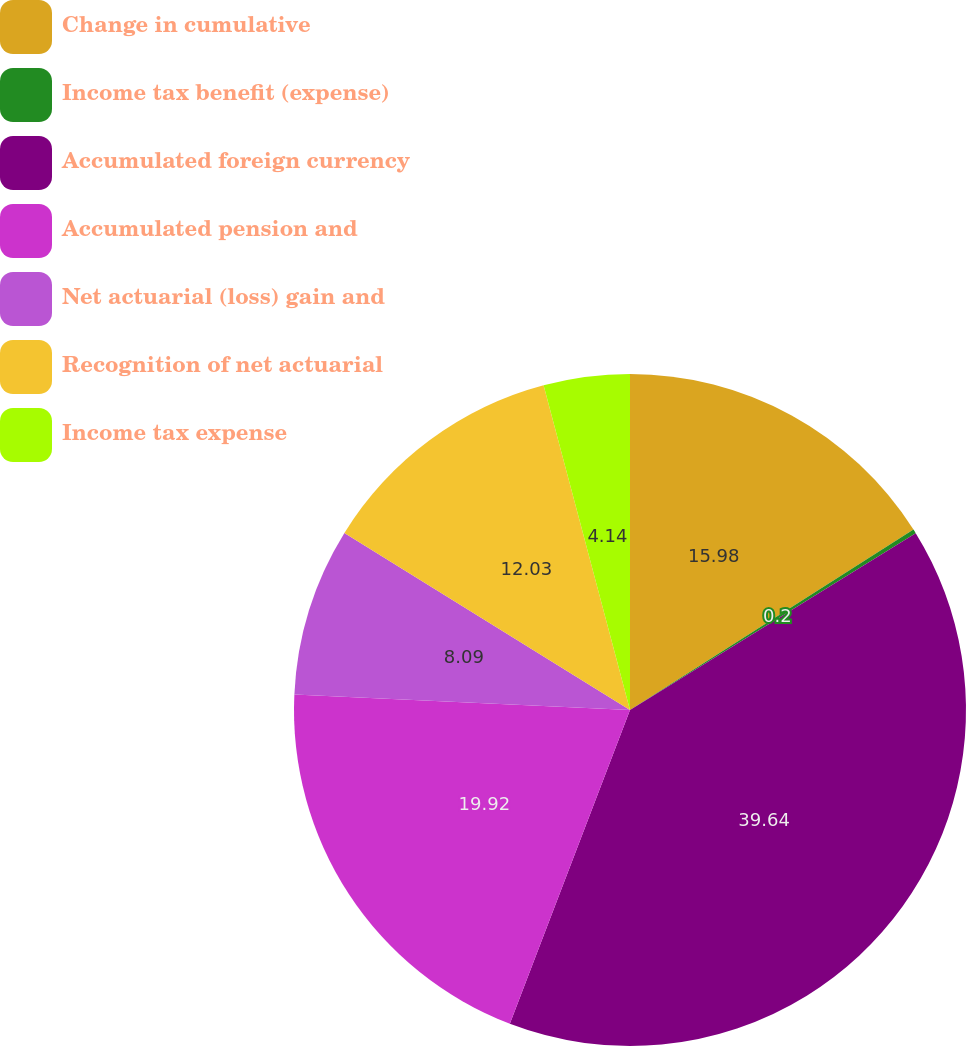Convert chart to OTSL. <chart><loc_0><loc_0><loc_500><loc_500><pie_chart><fcel>Change in cumulative<fcel>Income tax benefit (expense)<fcel>Accumulated foreign currency<fcel>Accumulated pension and<fcel>Net actuarial (loss) gain and<fcel>Recognition of net actuarial<fcel>Income tax expense<nl><fcel>15.98%<fcel>0.2%<fcel>39.64%<fcel>19.92%<fcel>8.09%<fcel>12.03%<fcel>4.14%<nl></chart> 